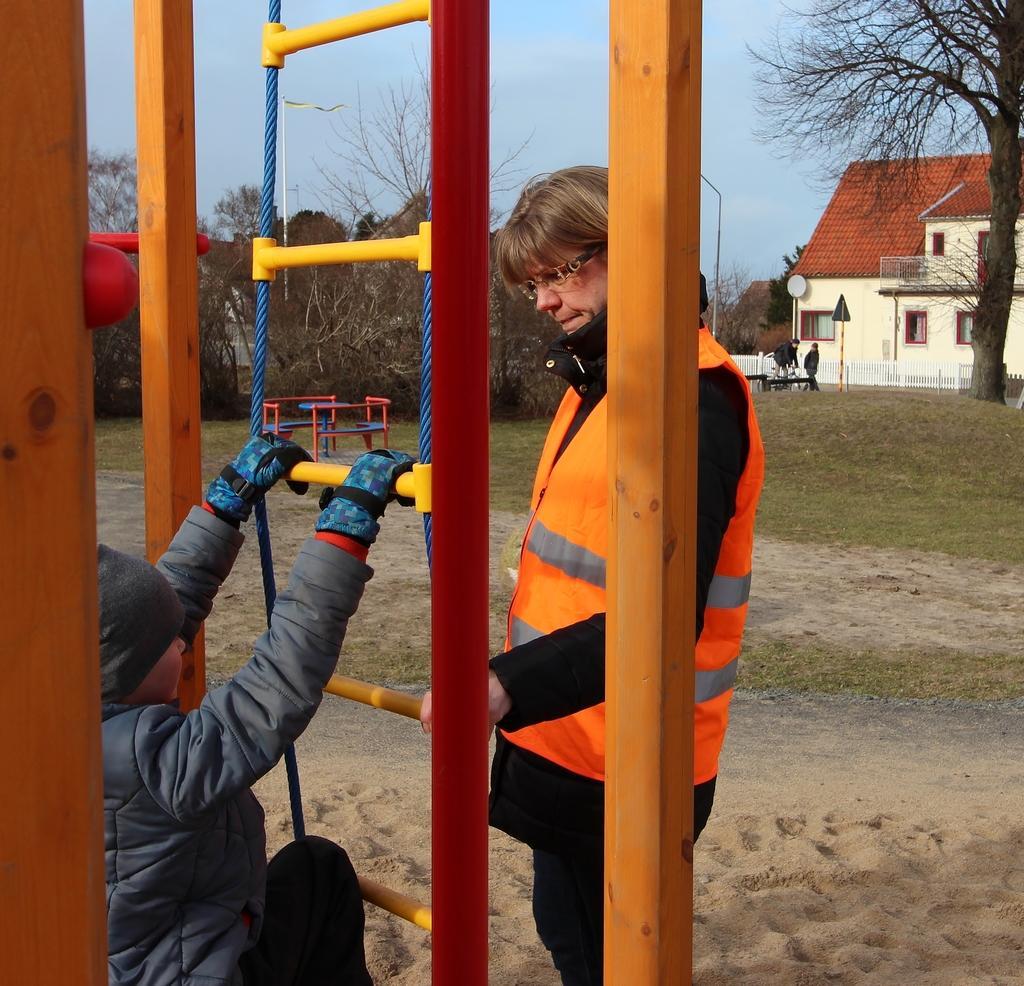How would you summarize this image in a sentence or two? In this image we can see a woman and a child. In that the child is holding a rope ladder. We can also see some grass, poles, a group of trees, some people standing, a fence, a house with roof and windows, a flag to a pole and the sky which looks cloudy. 